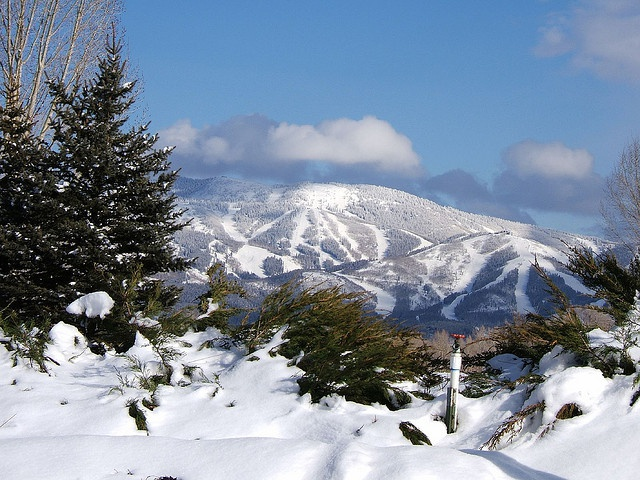Describe the objects in this image and their specific colors. I can see a fire hydrant in gray, white, darkgray, and black tones in this image. 